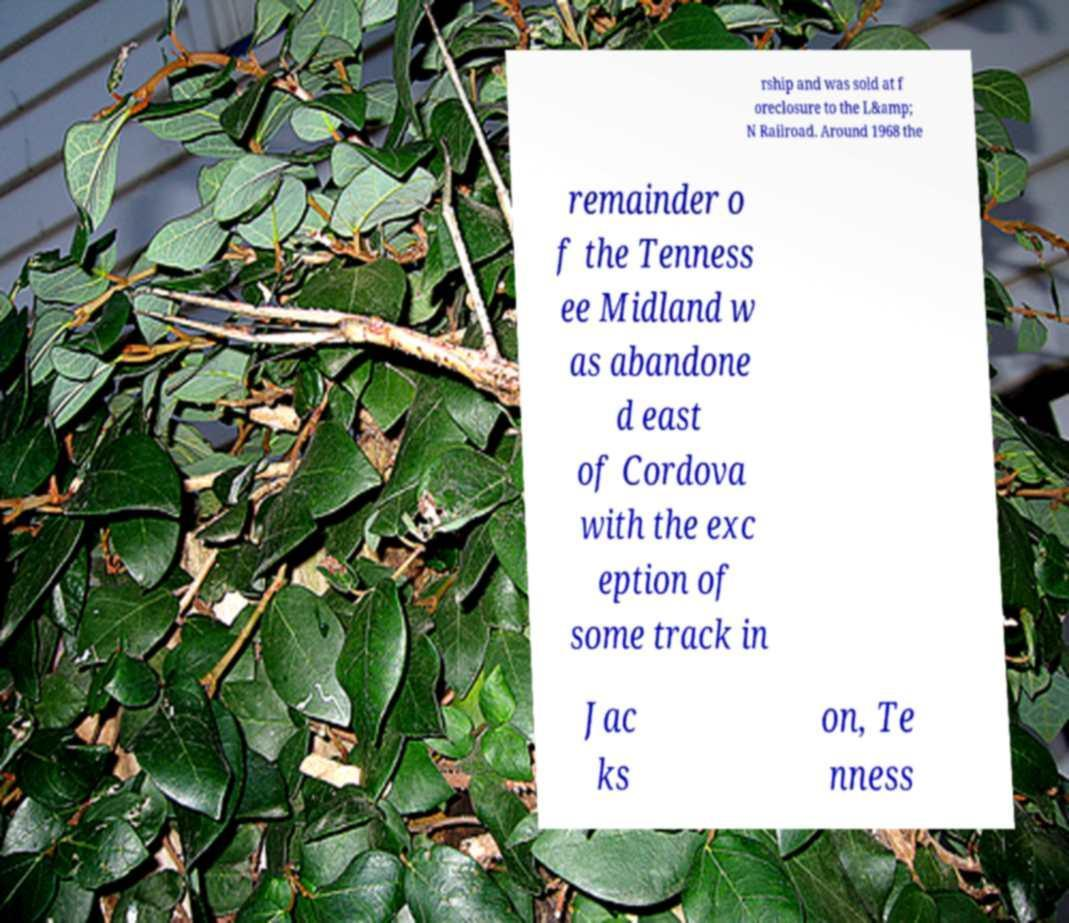For documentation purposes, I need the text within this image transcribed. Could you provide that? rship and was sold at f oreclosure to the L&amp; N Railroad. Around 1968 the remainder o f the Tenness ee Midland w as abandone d east of Cordova with the exc eption of some track in Jac ks on, Te nness 